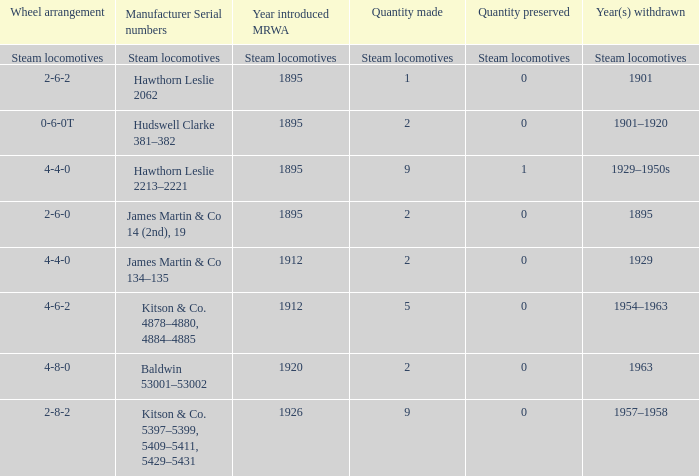In which year was the mrwa with a 4-6-2 wheel setup introduced? 1912.0. 